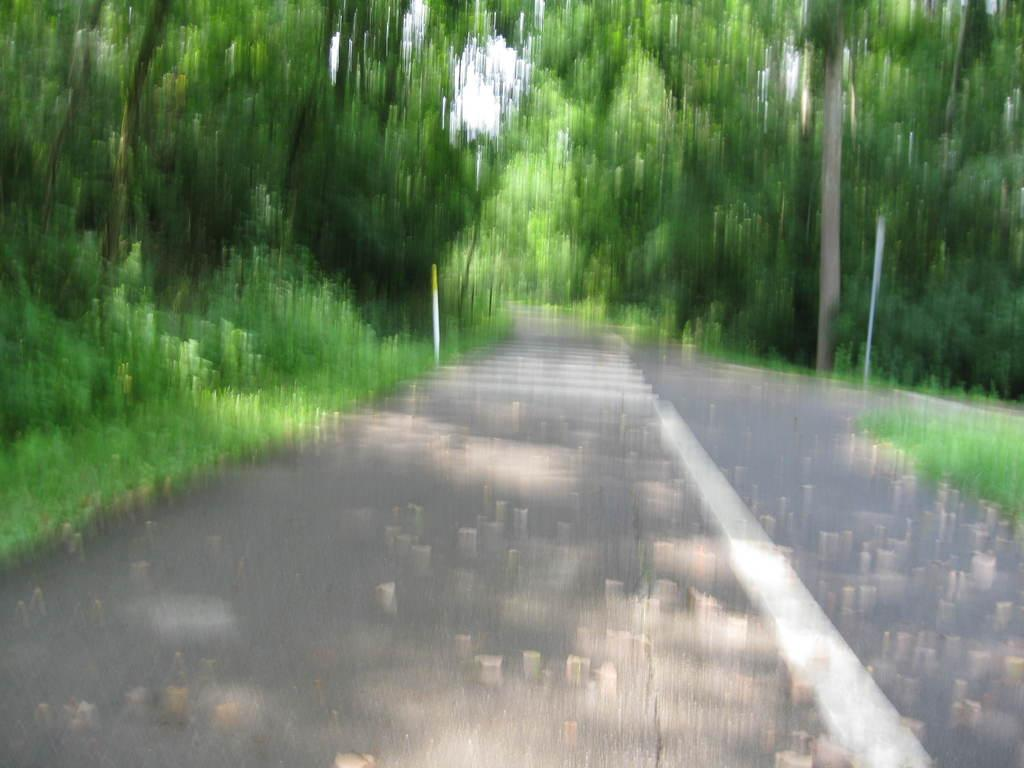What type of vegetation can be seen in the image? There are trees and grass in the image. What structures are present in the image? There are poles in the image. What is visible at the top of the image? The sky is visible at the top of the image. What is located at the bottom of the image? There is a road at the bottom of the image. What additional elements can be found in the image? Dried leaves are present in the image. Where is the girl playing in the image? There is no girl present in the image. What type of payment is required to enter the cave in the image? There is no cave or payment mentioned in the image. 